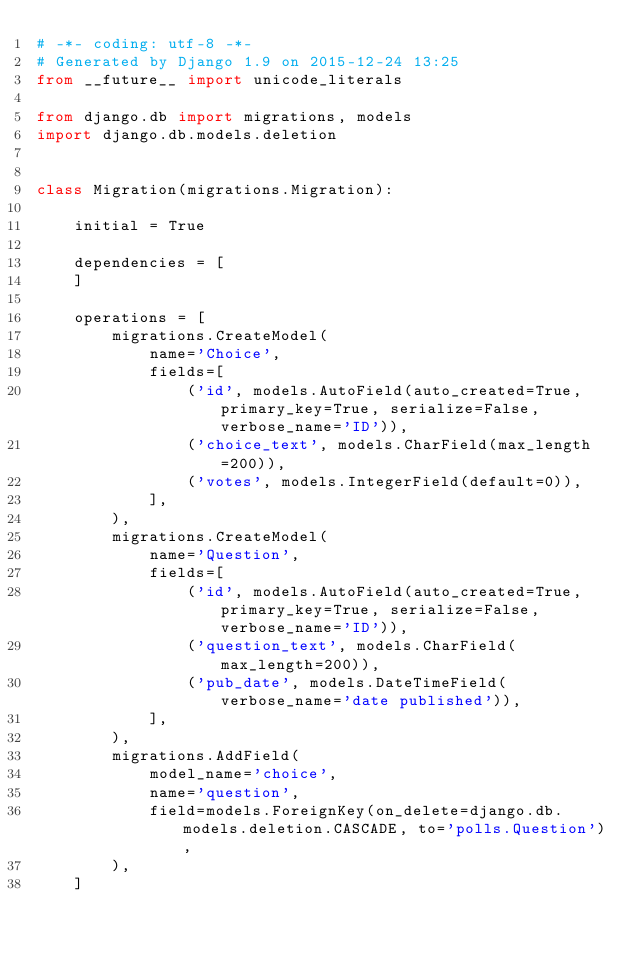<code> <loc_0><loc_0><loc_500><loc_500><_Python_># -*- coding: utf-8 -*-
# Generated by Django 1.9 on 2015-12-24 13:25
from __future__ import unicode_literals

from django.db import migrations, models
import django.db.models.deletion


class Migration(migrations.Migration):

    initial = True

    dependencies = [
    ]

    operations = [
        migrations.CreateModel(
            name='Choice',
            fields=[
                ('id', models.AutoField(auto_created=True, primary_key=True, serialize=False, verbose_name='ID')),
                ('choice_text', models.CharField(max_length=200)),
                ('votes', models.IntegerField(default=0)),
            ],
        ),
        migrations.CreateModel(
            name='Question',
            fields=[
                ('id', models.AutoField(auto_created=True, primary_key=True, serialize=False, verbose_name='ID')),
                ('question_text', models.CharField(max_length=200)),
                ('pub_date', models.DateTimeField(verbose_name='date published')),
            ],
        ),
        migrations.AddField(
            model_name='choice',
            name='question',
            field=models.ForeignKey(on_delete=django.db.models.deletion.CASCADE, to='polls.Question'),
        ),
    ]
</code> 